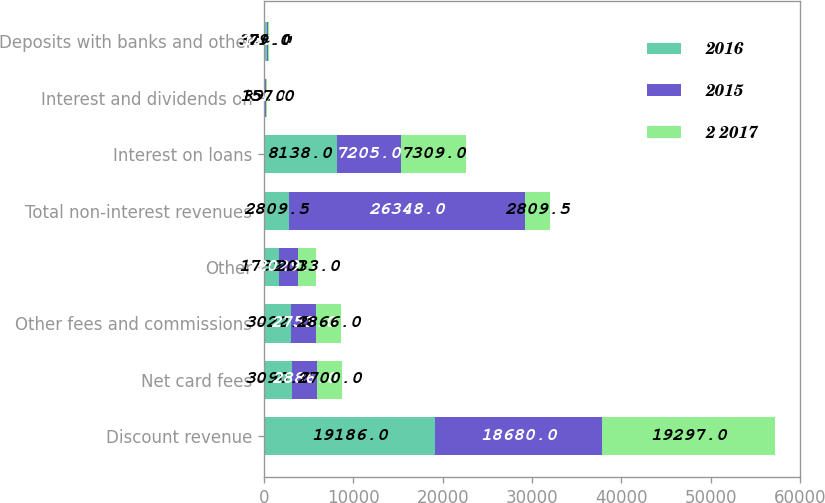Convert chart. <chart><loc_0><loc_0><loc_500><loc_500><stacked_bar_chart><ecel><fcel>Discount revenue<fcel>Net card fees<fcel>Other fees and commissions<fcel>Other<fcel>Total non-interest revenues<fcel>Interest on loans<fcel>Interest and dividends on<fcel>Deposits with banks and other<nl><fcel>2016<fcel>19186<fcel>3090<fcel>3022<fcel>1732<fcel>2809.5<fcel>8138<fcel>89<fcel>326<nl><fcel>2015<fcel>18680<fcel>2886<fcel>2753<fcel>2029<fcel>26348<fcel>7205<fcel>131<fcel>139<nl><fcel>2 2017<fcel>19297<fcel>2700<fcel>2866<fcel>2033<fcel>2809.5<fcel>7309<fcel>157<fcel>79<nl></chart> 